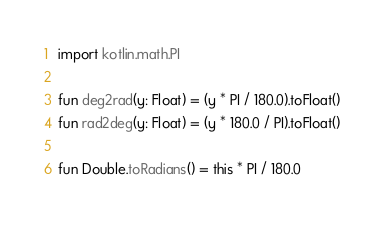<code> <loc_0><loc_0><loc_500><loc_500><_Kotlin_>import kotlin.math.PI

fun deg2rad(y: Float) = (y * PI / 180.0).toFloat()
fun rad2deg(y: Float) = (y * 180.0 / PI).toFloat()

fun Double.toRadians() = this * PI / 180.0</code> 